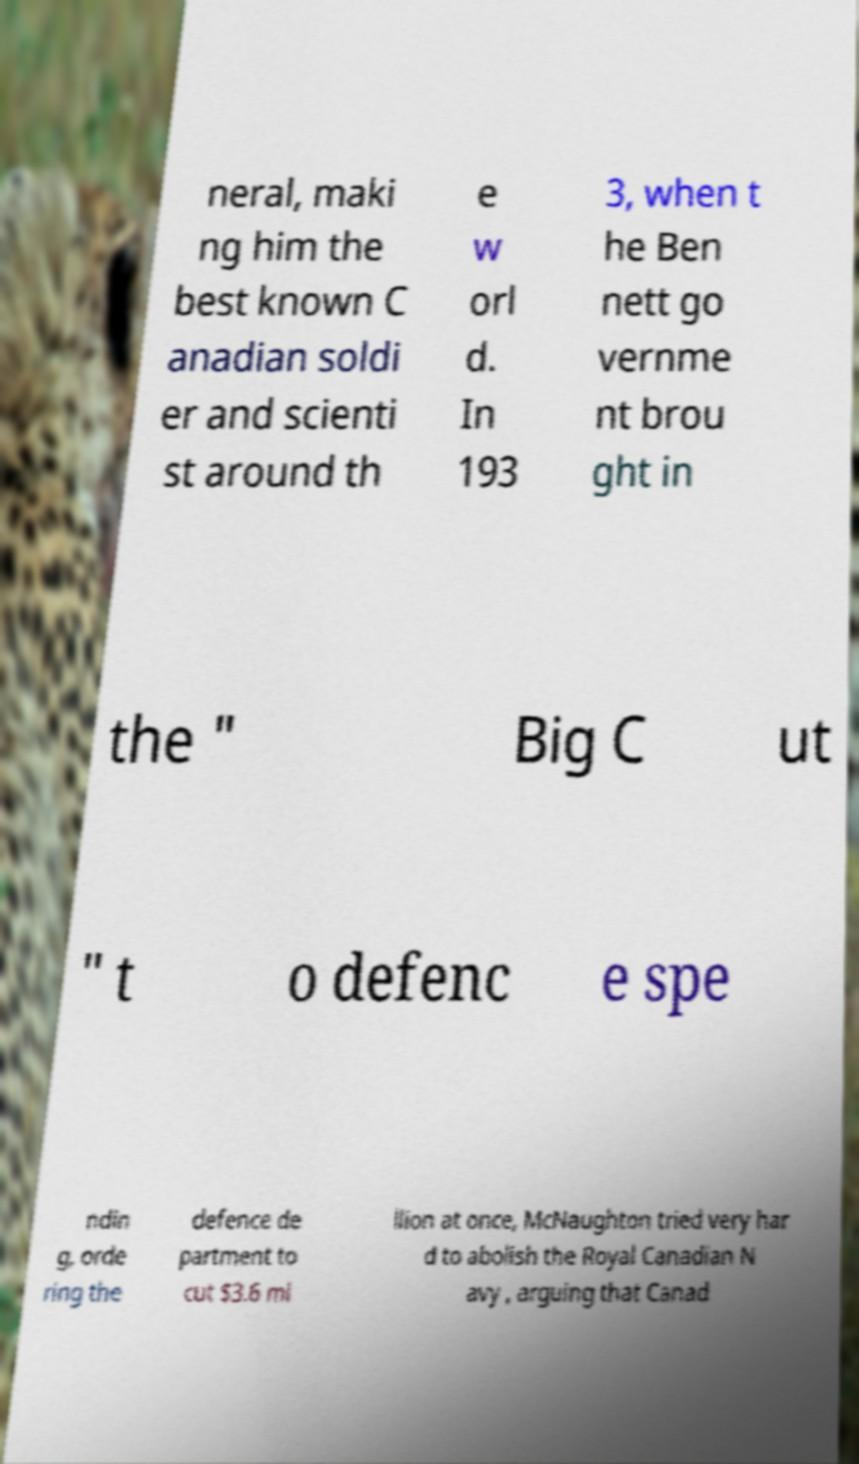Can you accurately transcribe the text from the provided image for me? neral, maki ng him the best known C anadian soldi er and scienti st around th e w orl d. In 193 3, when t he Ben nett go vernme nt brou ght in the " Big C ut " t o defenc e spe ndin g, orde ring the defence de partment to cut $3.6 mi llion at once, McNaughton tried very har d to abolish the Royal Canadian N avy , arguing that Canad 